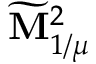Convert formula to latex. <formula><loc_0><loc_0><loc_500><loc_500>\widetilde { M } _ { 1 / \mu } ^ { 2 }</formula> 